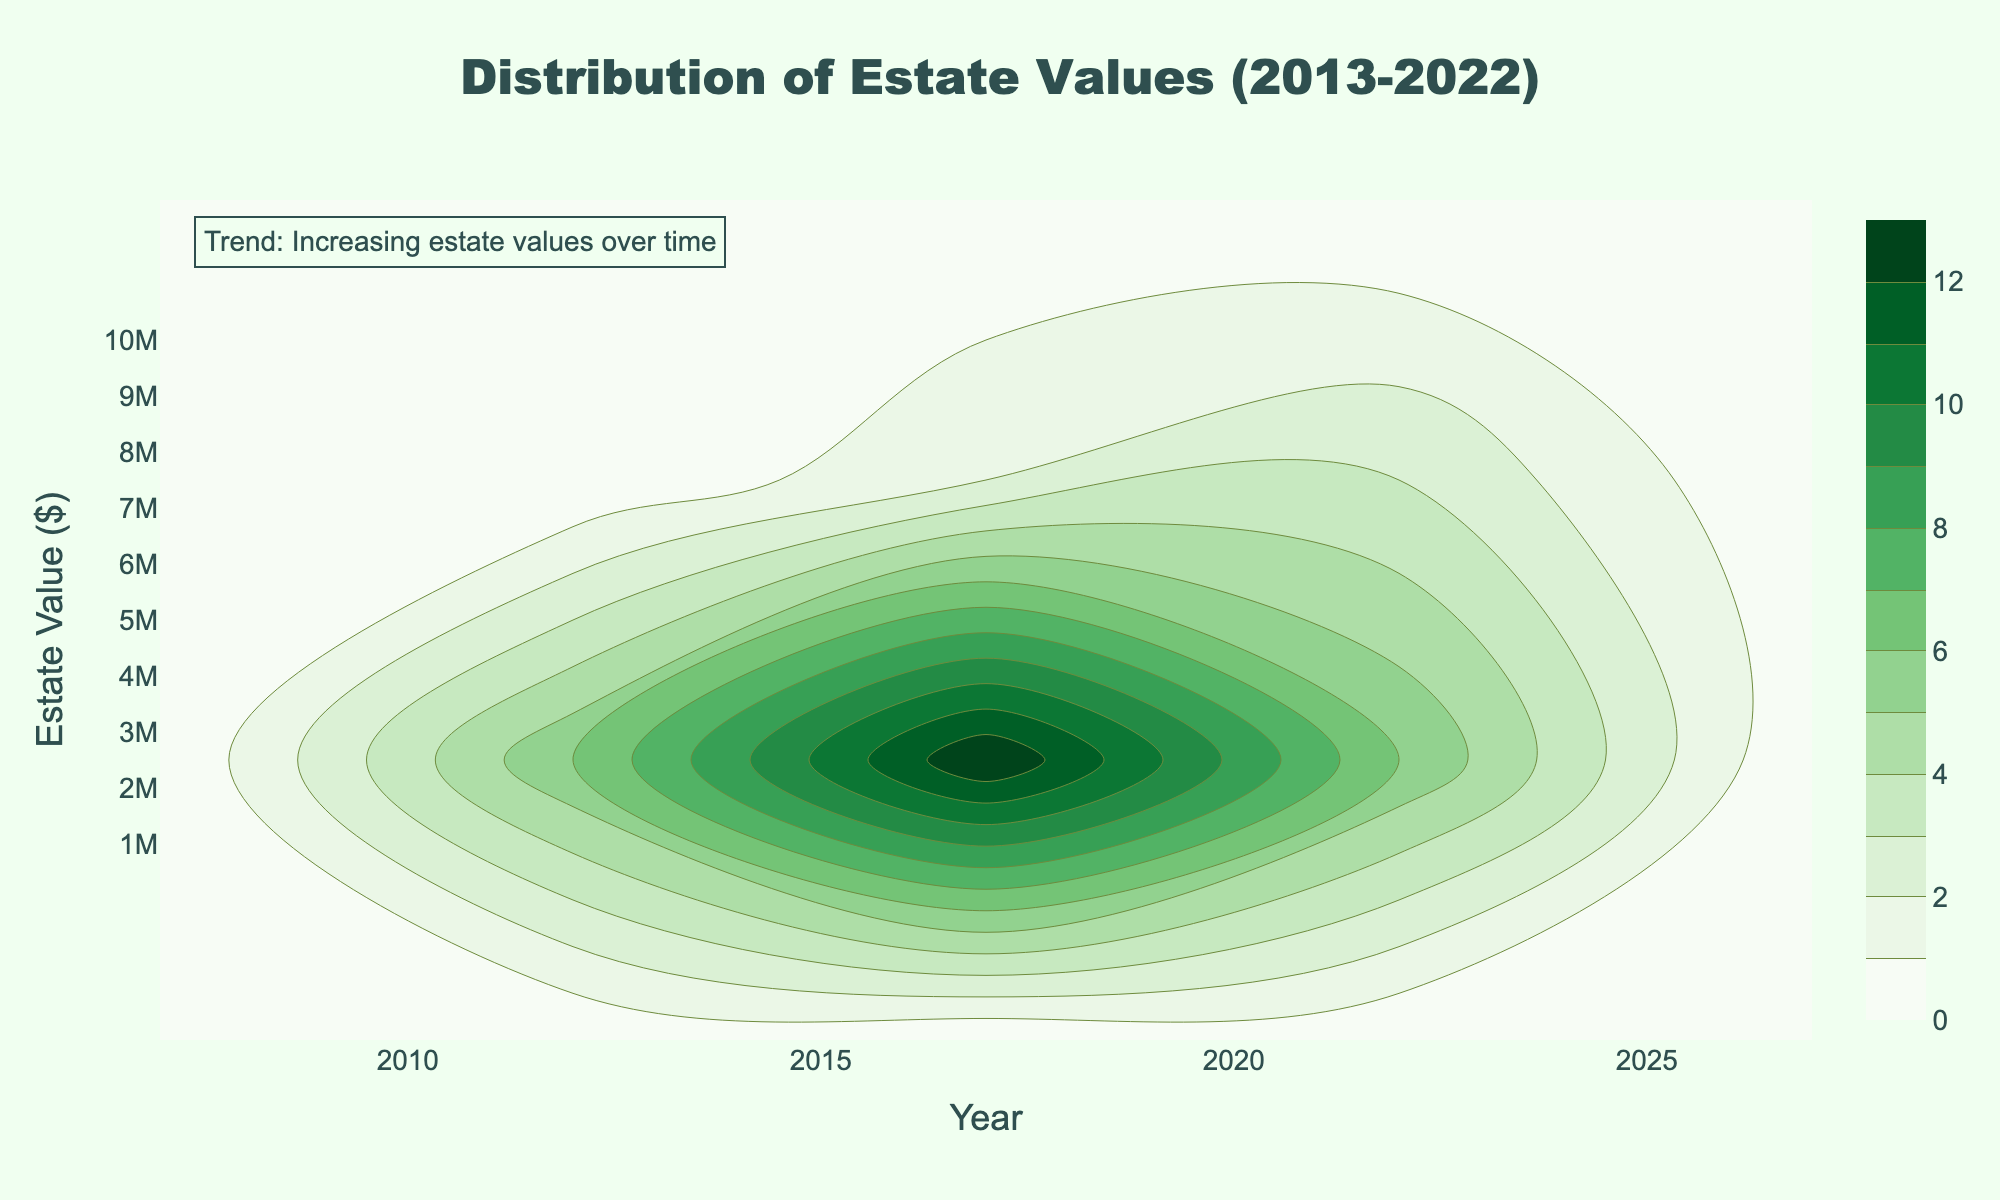What is the title of the plot? The title is located at the top center of the plot and is usually the largest text. It reads "Distribution of Estate Values (2013-2022)."
Answer: Distribution of Estate Values (2013-2022) What is the x-axis labeled as? The x-axis label is found just below the horizontal axis, it specifies what the axis represents. It says "Year."
Answer: Year What is the highest estate value shown in the plot? The highest value can be found by looking at the maximum point on the y-axis, which is scaled in millions. The highest estate value is 10 million dollars.
Answer: 10 million dollars What is the color used for the plot's background? The background color can be identified by observing the area behind the chart elements. It is a light green shade.
Answer: Light green Which year has the widest distribution of estate values? By looking at the plot's density contours, identify the year where the vertical spread of estate values is the widest. 2022 stands out as having the widest distribution, indicating diverse estate values in that year.
Answer: 2022 Between 2013 and 2015, which year had the highest estate value? Analyze the plot for the points corresponding to 2013, 2014, and 2015 and compare their highest estate values. 2015 shows the highest value reaching around 4 million dollars.
Answer: 2015 What is the general trend in estate values over time? Observe the plot from left to right to determine if there is a noticeable pattern. There is an annotation on the plot and visually, estate values tend to increase over the years from 2013 to 2022.
Answer: Increasing estate values Which year shows the smallest range of estate values? Examine the density contours and identify the year where the vertical spread is the narrowest. 2013 shows the smallest range of estate values.
Answer: 2013 Compare the estate values in 2017 and 2019. Are they similar in range? Look at the plot's density contours for 2017 and 2019. Both years have a relatively wide range of values, but the maximum value for 2019 is higher, suggesting a greater spread in the latter year.
Answer: No, 2019 has a higher maximum What is the range of estate values in 2020? Identify the lowest and highest points in 2020 by observing the y-axis span covered by the density contours. The estate values range from around 810,000 dollars to approximately 7.1 million dollars.
Answer: Around 810,000 to 7.1 million dollars 